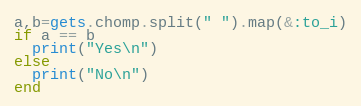<code> <loc_0><loc_0><loc_500><loc_500><_Ruby_>a,b=gets.chomp.split(" ").map(&:to_i)
if a == b
  print("Yes\n")
else
  print("No\n")
end</code> 